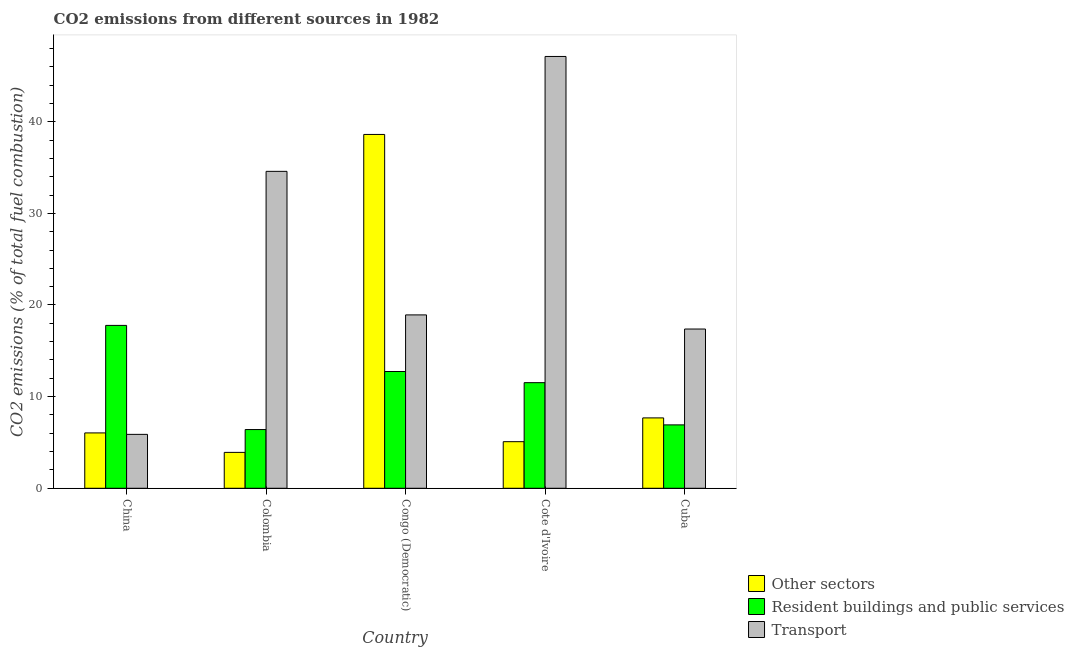How many different coloured bars are there?
Your answer should be compact. 3. Are the number of bars per tick equal to the number of legend labels?
Your answer should be very brief. Yes. How many bars are there on the 5th tick from the left?
Offer a terse response. 3. What is the label of the 3rd group of bars from the left?
Your response must be concise. Congo (Democratic). What is the percentage of co2 emissions from resident buildings and public services in China?
Your answer should be compact. 17.77. Across all countries, what is the maximum percentage of co2 emissions from resident buildings and public services?
Ensure brevity in your answer.  17.77. Across all countries, what is the minimum percentage of co2 emissions from resident buildings and public services?
Provide a succinct answer. 6.41. What is the total percentage of co2 emissions from other sectors in the graph?
Provide a succinct answer. 61.33. What is the difference between the percentage of co2 emissions from resident buildings and public services in China and that in Cuba?
Your answer should be very brief. 10.85. What is the difference between the percentage of co2 emissions from resident buildings and public services in Cuba and the percentage of co2 emissions from other sectors in Colombia?
Give a very brief answer. 3. What is the average percentage of co2 emissions from transport per country?
Provide a succinct answer. 24.78. What is the difference between the percentage of co2 emissions from transport and percentage of co2 emissions from resident buildings and public services in China?
Your answer should be compact. -11.89. In how many countries, is the percentage of co2 emissions from other sectors greater than 34 %?
Offer a terse response. 1. What is the ratio of the percentage of co2 emissions from other sectors in Colombia to that in Cuba?
Provide a short and direct response. 0.51. What is the difference between the highest and the second highest percentage of co2 emissions from resident buildings and public services?
Ensure brevity in your answer.  5.03. What is the difference between the highest and the lowest percentage of co2 emissions from transport?
Make the answer very short. 41.24. In how many countries, is the percentage of co2 emissions from transport greater than the average percentage of co2 emissions from transport taken over all countries?
Your answer should be very brief. 2. What does the 3rd bar from the left in China represents?
Your answer should be compact. Transport. What does the 3rd bar from the right in Congo (Democratic) represents?
Your answer should be very brief. Other sectors. How many bars are there?
Your answer should be compact. 15. Are all the bars in the graph horizontal?
Provide a short and direct response. No. How many countries are there in the graph?
Offer a terse response. 5. Are the values on the major ticks of Y-axis written in scientific E-notation?
Your answer should be very brief. No. Does the graph contain any zero values?
Your answer should be very brief. No. Where does the legend appear in the graph?
Your response must be concise. Bottom right. How many legend labels are there?
Your response must be concise. 3. What is the title of the graph?
Keep it short and to the point. CO2 emissions from different sources in 1982. Does "Labor Tax" appear as one of the legend labels in the graph?
Make the answer very short. No. What is the label or title of the Y-axis?
Provide a succinct answer. CO2 emissions (% of total fuel combustion). What is the CO2 emissions (% of total fuel combustion) of Other sectors in China?
Offer a terse response. 6.04. What is the CO2 emissions (% of total fuel combustion) in Resident buildings and public services in China?
Offer a terse response. 17.77. What is the CO2 emissions (% of total fuel combustion) of Transport in China?
Make the answer very short. 5.88. What is the CO2 emissions (% of total fuel combustion) of Other sectors in Colombia?
Provide a short and direct response. 3.92. What is the CO2 emissions (% of total fuel combustion) in Resident buildings and public services in Colombia?
Give a very brief answer. 6.41. What is the CO2 emissions (% of total fuel combustion) of Transport in Colombia?
Ensure brevity in your answer.  34.58. What is the CO2 emissions (% of total fuel combustion) of Other sectors in Congo (Democratic)?
Offer a very short reply. 38.61. What is the CO2 emissions (% of total fuel combustion) of Resident buildings and public services in Congo (Democratic)?
Make the answer very short. 12.74. What is the CO2 emissions (% of total fuel combustion) of Transport in Congo (Democratic)?
Ensure brevity in your answer.  18.92. What is the CO2 emissions (% of total fuel combustion) of Other sectors in Cote d'Ivoire?
Ensure brevity in your answer.  5.08. What is the CO2 emissions (% of total fuel combustion) in Resident buildings and public services in Cote d'Ivoire?
Your answer should be compact. 11.53. What is the CO2 emissions (% of total fuel combustion) of Transport in Cote d'Ivoire?
Offer a very short reply. 47.12. What is the CO2 emissions (% of total fuel combustion) of Other sectors in Cuba?
Keep it short and to the point. 7.68. What is the CO2 emissions (% of total fuel combustion) in Resident buildings and public services in Cuba?
Provide a succinct answer. 6.92. What is the CO2 emissions (% of total fuel combustion) in Transport in Cuba?
Provide a short and direct response. 17.38. Across all countries, what is the maximum CO2 emissions (% of total fuel combustion) of Other sectors?
Offer a terse response. 38.61. Across all countries, what is the maximum CO2 emissions (% of total fuel combustion) of Resident buildings and public services?
Your answer should be compact. 17.77. Across all countries, what is the maximum CO2 emissions (% of total fuel combustion) in Transport?
Keep it short and to the point. 47.12. Across all countries, what is the minimum CO2 emissions (% of total fuel combustion) in Other sectors?
Keep it short and to the point. 3.92. Across all countries, what is the minimum CO2 emissions (% of total fuel combustion) of Resident buildings and public services?
Your answer should be very brief. 6.41. Across all countries, what is the minimum CO2 emissions (% of total fuel combustion) in Transport?
Make the answer very short. 5.88. What is the total CO2 emissions (% of total fuel combustion) in Other sectors in the graph?
Offer a terse response. 61.33. What is the total CO2 emissions (% of total fuel combustion) in Resident buildings and public services in the graph?
Your answer should be compact. 55.37. What is the total CO2 emissions (% of total fuel combustion) of Transport in the graph?
Keep it short and to the point. 123.88. What is the difference between the CO2 emissions (% of total fuel combustion) of Other sectors in China and that in Colombia?
Make the answer very short. 2.12. What is the difference between the CO2 emissions (% of total fuel combustion) of Resident buildings and public services in China and that in Colombia?
Offer a terse response. 11.37. What is the difference between the CO2 emissions (% of total fuel combustion) of Transport in China and that in Colombia?
Offer a very short reply. -28.7. What is the difference between the CO2 emissions (% of total fuel combustion) of Other sectors in China and that in Congo (Democratic)?
Your response must be concise. -32.57. What is the difference between the CO2 emissions (% of total fuel combustion) of Resident buildings and public services in China and that in Congo (Democratic)?
Make the answer very short. 5.03. What is the difference between the CO2 emissions (% of total fuel combustion) in Transport in China and that in Congo (Democratic)?
Keep it short and to the point. -13.04. What is the difference between the CO2 emissions (% of total fuel combustion) in Other sectors in China and that in Cote d'Ivoire?
Keep it short and to the point. 0.96. What is the difference between the CO2 emissions (% of total fuel combustion) in Resident buildings and public services in China and that in Cote d'Ivoire?
Provide a short and direct response. 6.25. What is the difference between the CO2 emissions (% of total fuel combustion) in Transport in China and that in Cote d'Ivoire?
Keep it short and to the point. -41.24. What is the difference between the CO2 emissions (% of total fuel combustion) in Other sectors in China and that in Cuba?
Your response must be concise. -1.64. What is the difference between the CO2 emissions (% of total fuel combustion) of Resident buildings and public services in China and that in Cuba?
Your answer should be compact. 10.85. What is the difference between the CO2 emissions (% of total fuel combustion) of Transport in China and that in Cuba?
Provide a succinct answer. -11.5. What is the difference between the CO2 emissions (% of total fuel combustion) in Other sectors in Colombia and that in Congo (Democratic)?
Your answer should be compact. -34.69. What is the difference between the CO2 emissions (% of total fuel combustion) of Resident buildings and public services in Colombia and that in Congo (Democratic)?
Offer a terse response. -6.33. What is the difference between the CO2 emissions (% of total fuel combustion) in Transport in Colombia and that in Congo (Democratic)?
Keep it short and to the point. 15.66. What is the difference between the CO2 emissions (% of total fuel combustion) in Other sectors in Colombia and that in Cote d'Ivoire?
Offer a terse response. -1.17. What is the difference between the CO2 emissions (% of total fuel combustion) of Resident buildings and public services in Colombia and that in Cote d'Ivoire?
Offer a terse response. -5.12. What is the difference between the CO2 emissions (% of total fuel combustion) of Transport in Colombia and that in Cote d'Ivoire?
Make the answer very short. -12.54. What is the difference between the CO2 emissions (% of total fuel combustion) in Other sectors in Colombia and that in Cuba?
Give a very brief answer. -3.76. What is the difference between the CO2 emissions (% of total fuel combustion) of Resident buildings and public services in Colombia and that in Cuba?
Your response must be concise. -0.51. What is the difference between the CO2 emissions (% of total fuel combustion) of Transport in Colombia and that in Cuba?
Your answer should be very brief. 17.2. What is the difference between the CO2 emissions (% of total fuel combustion) in Other sectors in Congo (Democratic) and that in Cote d'Ivoire?
Make the answer very short. 33.53. What is the difference between the CO2 emissions (% of total fuel combustion) of Resident buildings and public services in Congo (Democratic) and that in Cote d'Ivoire?
Give a very brief answer. 1.22. What is the difference between the CO2 emissions (% of total fuel combustion) in Transport in Congo (Democratic) and that in Cote d'Ivoire?
Your answer should be very brief. -28.2. What is the difference between the CO2 emissions (% of total fuel combustion) of Other sectors in Congo (Democratic) and that in Cuba?
Offer a terse response. 30.93. What is the difference between the CO2 emissions (% of total fuel combustion) of Resident buildings and public services in Congo (Democratic) and that in Cuba?
Keep it short and to the point. 5.82. What is the difference between the CO2 emissions (% of total fuel combustion) of Transport in Congo (Democratic) and that in Cuba?
Provide a succinct answer. 1.54. What is the difference between the CO2 emissions (% of total fuel combustion) of Other sectors in Cote d'Ivoire and that in Cuba?
Your response must be concise. -2.59. What is the difference between the CO2 emissions (% of total fuel combustion) in Resident buildings and public services in Cote d'Ivoire and that in Cuba?
Provide a short and direct response. 4.61. What is the difference between the CO2 emissions (% of total fuel combustion) in Transport in Cote d'Ivoire and that in Cuba?
Make the answer very short. 29.74. What is the difference between the CO2 emissions (% of total fuel combustion) in Other sectors in China and the CO2 emissions (% of total fuel combustion) in Resident buildings and public services in Colombia?
Make the answer very short. -0.37. What is the difference between the CO2 emissions (% of total fuel combustion) of Other sectors in China and the CO2 emissions (% of total fuel combustion) of Transport in Colombia?
Provide a succinct answer. -28.54. What is the difference between the CO2 emissions (% of total fuel combustion) of Resident buildings and public services in China and the CO2 emissions (% of total fuel combustion) of Transport in Colombia?
Your answer should be compact. -16.81. What is the difference between the CO2 emissions (% of total fuel combustion) of Other sectors in China and the CO2 emissions (% of total fuel combustion) of Resident buildings and public services in Congo (Democratic)?
Your response must be concise. -6.7. What is the difference between the CO2 emissions (% of total fuel combustion) in Other sectors in China and the CO2 emissions (% of total fuel combustion) in Transport in Congo (Democratic)?
Keep it short and to the point. -12.88. What is the difference between the CO2 emissions (% of total fuel combustion) in Resident buildings and public services in China and the CO2 emissions (% of total fuel combustion) in Transport in Congo (Democratic)?
Your answer should be compact. -1.15. What is the difference between the CO2 emissions (% of total fuel combustion) of Other sectors in China and the CO2 emissions (% of total fuel combustion) of Resident buildings and public services in Cote d'Ivoire?
Ensure brevity in your answer.  -5.48. What is the difference between the CO2 emissions (% of total fuel combustion) in Other sectors in China and the CO2 emissions (% of total fuel combustion) in Transport in Cote d'Ivoire?
Your answer should be compact. -41.08. What is the difference between the CO2 emissions (% of total fuel combustion) of Resident buildings and public services in China and the CO2 emissions (% of total fuel combustion) of Transport in Cote d'Ivoire?
Your answer should be compact. -29.35. What is the difference between the CO2 emissions (% of total fuel combustion) of Other sectors in China and the CO2 emissions (% of total fuel combustion) of Resident buildings and public services in Cuba?
Offer a very short reply. -0.88. What is the difference between the CO2 emissions (% of total fuel combustion) in Other sectors in China and the CO2 emissions (% of total fuel combustion) in Transport in Cuba?
Offer a very short reply. -11.34. What is the difference between the CO2 emissions (% of total fuel combustion) in Resident buildings and public services in China and the CO2 emissions (% of total fuel combustion) in Transport in Cuba?
Your answer should be very brief. 0.39. What is the difference between the CO2 emissions (% of total fuel combustion) in Other sectors in Colombia and the CO2 emissions (% of total fuel combustion) in Resident buildings and public services in Congo (Democratic)?
Provide a succinct answer. -8.82. What is the difference between the CO2 emissions (% of total fuel combustion) in Other sectors in Colombia and the CO2 emissions (% of total fuel combustion) in Transport in Congo (Democratic)?
Your answer should be very brief. -15. What is the difference between the CO2 emissions (% of total fuel combustion) of Resident buildings and public services in Colombia and the CO2 emissions (% of total fuel combustion) of Transport in Congo (Democratic)?
Provide a succinct answer. -12.51. What is the difference between the CO2 emissions (% of total fuel combustion) in Other sectors in Colombia and the CO2 emissions (% of total fuel combustion) in Resident buildings and public services in Cote d'Ivoire?
Your answer should be compact. -7.61. What is the difference between the CO2 emissions (% of total fuel combustion) of Other sectors in Colombia and the CO2 emissions (% of total fuel combustion) of Transport in Cote d'Ivoire?
Give a very brief answer. -43.2. What is the difference between the CO2 emissions (% of total fuel combustion) in Resident buildings and public services in Colombia and the CO2 emissions (% of total fuel combustion) in Transport in Cote d'Ivoire?
Offer a very short reply. -40.71. What is the difference between the CO2 emissions (% of total fuel combustion) in Other sectors in Colombia and the CO2 emissions (% of total fuel combustion) in Resident buildings and public services in Cuba?
Offer a terse response. -3. What is the difference between the CO2 emissions (% of total fuel combustion) of Other sectors in Colombia and the CO2 emissions (% of total fuel combustion) of Transport in Cuba?
Your response must be concise. -13.46. What is the difference between the CO2 emissions (% of total fuel combustion) in Resident buildings and public services in Colombia and the CO2 emissions (% of total fuel combustion) in Transport in Cuba?
Offer a terse response. -10.97. What is the difference between the CO2 emissions (% of total fuel combustion) of Other sectors in Congo (Democratic) and the CO2 emissions (% of total fuel combustion) of Resident buildings and public services in Cote d'Ivoire?
Ensure brevity in your answer.  27.08. What is the difference between the CO2 emissions (% of total fuel combustion) in Other sectors in Congo (Democratic) and the CO2 emissions (% of total fuel combustion) in Transport in Cote d'Ivoire?
Keep it short and to the point. -8.51. What is the difference between the CO2 emissions (% of total fuel combustion) in Resident buildings and public services in Congo (Democratic) and the CO2 emissions (% of total fuel combustion) in Transport in Cote d'Ivoire?
Offer a terse response. -34.38. What is the difference between the CO2 emissions (% of total fuel combustion) in Other sectors in Congo (Democratic) and the CO2 emissions (% of total fuel combustion) in Resident buildings and public services in Cuba?
Provide a short and direct response. 31.69. What is the difference between the CO2 emissions (% of total fuel combustion) in Other sectors in Congo (Democratic) and the CO2 emissions (% of total fuel combustion) in Transport in Cuba?
Ensure brevity in your answer.  21.23. What is the difference between the CO2 emissions (% of total fuel combustion) in Resident buildings and public services in Congo (Democratic) and the CO2 emissions (% of total fuel combustion) in Transport in Cuba?
Give a very brief answer. -4.64. What is the difference between the CO2 emissions (% of total fuel combustion) of Other sectors in Cote d'Ivoire and the CO2 emissions (% of total fuel combustion) of Resident buildings and public services in Cuba?
Give a very brief answer. -1.83. What is the difference between the CO2 emissions (% of total fuel combustion) of Other sectors in Cote d'Ivoire and the CO2 emissions (% of total fuel combustion) of Transport in Cuba?
Provide a short and direct response. -12.29. What is the difference between the CO2 emissions (% of total fuel combustion) of Resident buildings and public services in Cote d'Ivoire and the CO2 emissions (% of total fuel combustion) of Transport in Cuba?
Provide a succinct answer. -5.85. What is the average CO2 emissions (% of total fuel combustion) of Other sectors per country?
Offer a very short reply. 12.27. What is the average CO2 emissions (% of total fuel combustion) of Resident buildings and public services per country?
Keep it short and to the point. 11.07. What is the average CO2 emissions (% of total fuel combustion) in Transport per country?
Provide a short and direct response. 24.78. What is the difference between the CO2 emissions (% of total fuel combustion) in Other sectors and CO2 emissions (% of total fuel combustion) in Resident buildings and public services in China?
Your answer should be very brief. -11.73. What is the difference between the CO2 emissions (% of total fuel combustion) in Other sectors and CO2 emissions (% of total fuel combustion) in Transport in China?
Your response must be concise. 0.16. What is the difference between the CO2 emissions (% of total fuel combustion) of Resident buildings and public services and CO2 emissions (% of total fuel combustion) of Transport in China?
Your answer should be compact. 11.89. What is the difference between the CO2 emissions (% of total fuel combustion) of Other sectors and CO2 emissions (% of total fuel combustion) of Resident buildings and public services in Colombia?
Give a very brief answer. -2.49. What is the difference between the CO2 emissions (% of total fuel combustion) in Other sectors and CO2 emissions (% of total fuel combustion) in Transport in Colombia?
Ensure brevity in your answer.  -30.67. What is the difference between the CO2 emissions (% of total fuel combustion) in Resident buildings and public services and CO2 emissions (% of total fuel combustion) in Transport in Colombia?
Offer a terse response. -28.18. What is the difference between the CO2 emissions (% of total fuel combustion) in Other sectors and CO2 emissions (% of total fuel combustion) in Resident buildings and public services in Congo (Democratic)?
Ensure brevity in your answer.  25.87. What is the difference between the CO2 emissions (% of total fuel combustion) in Other sectors and CO2 emissions (% of total fuel combustion) in Transport in Congo (Democratic)?
Offer a terse response. 19.69. What is the difference between the CO2 emissions (% of total fuel combustion) in Resident buildings and public services and CO2 emissions (% of total fuel combustion) in Transport in Congo (Democratic)?
Provide a succinct answer. -6.18. What is the difference between the CO2 emissions (% of total fuel combustion) of Other sectors and CO2 emissions (% of total fuel combustion) of Resident buildings and public services in Cote d'Ivoire?
Offer a terse response. -6.44. What is the difference between the CO2 emissions (% of total fuel combustion) in Other sectors and CO2 emissions (% of total fuel combustion) in Transport in Cote d'Ivoire?
Give a very brief answer. -42.03. What is the difference between the CO2 emissions (% of total fuel combustion) in Resident buildings and public services and CO2 emissions (% of total fuel combustion) in Transport in Cote d'Ivoire?
Your answer should be very brief. -35.59. What is the difference between the CO2 emissions (% of total fuel combustion) of Other sectors and CO2 emissions (% of total fuel combustion) of Resident buildings and public services in Cuba?
Ensure brevity in your answer.  0.76. What is the difference between the CO2 emissions (% of total fuel combustion) of Other sectors and CO2 emissions (% of total fuel combustion) of Transport in Cuba?
Give a very brief answer. -9.7. What is the difference between the CO2 emissions (% of total fuel combustion) of Resident buildings and public services and CO2 emissions (% of total fuel combustion) of Transport in Cuba?
Make the answer very short. -10.46. What is the ratio of the CO2 emissions (% of total fuel combustion) in Other sectors in China to that in Colombia?
Your answer should be very brief. 1.54. What is the ratio of the CO2 emissions (% of total fuel combustion) in Resident buildings and public services in China to that in Colombia?
Keep it short and to the point. 2.77. What is the ratio of the CO2 emissions (% of total fuel combustion) of Transport in China to that in Colombia?
Your answer should be compact. 0.17. What is the ratio of the CO2 emissions (% of total fuel combustion) of Other sectors in China to that in Congo (Democratic)?
Provide a succinct answer. 0.16. What is the ratio of the CO2 emissions (% of total fuel combustion) of Resident buildings and public services in China to that in Congo (Democratic)?
Your answer should be very brief. 1.39. What is the ratio of the CO2 emissions (% of total fuel combustion) of Transport in China to that in Congo (Democratic)?
Provide a succinct answer. 0.31. What is the ratio of the CO2 emissions (% of total fuel combustion) in Other sectors in China to that in Cote d'Ivoire?
Provide a short and direct response. 1.19. What is the ratio of the CO2 emissions (% of total fuel combustion) of Resident buildings and public services in China to that in Cote d'Ivoire?
Your answer should be compact. 1.54. What is the ratio of the CO2 emissions (% of total fuel combustion) in Transport in China to that in Cote d'Ivoire?
Offer a terse response. 0.12. What is the ratio of the CO2 emissions (% of total fuel combustion) in Other sectors in China to that in Cuba?
Offer a very short reply. 0.79. What is the ratio of the CO2 emissions (% of total fuel combustion) in Resident buildings and public services in China to that in Cuba?
Give a very brief answer. 2.57. What is the ratio of the CO2 emissions (% of total fuel combustion) in Transport in China to that in Cuba?
Ensure brevity in your answer.  0.34. What is the ratio of the CO2 emissions (% of total fuel combustion) of Other sectors in Colombia to that in Congo (Democratic)?
Keep it short and to the point. 0.1. What is the ratio of the CO2 emissions (% of total fuel combustion) in Resident buildings and public services in Colombia to that in Congo (Democratic)?
Offer a terse response. 0.5. What is the ratio of the CO2 emissions (% of total fuel combustion) in Transport in Colombia to that in Congo (Democratic)?
Offer a terse response. 1.83. What is the ratio of the CO2 emissions (% of total fuel combustion) of Other sectors in Colombia to that in Cote d'Ivoire?
Your answer should be compact. 0.77. What is the ratio of the CO2 emissions (% of total fuel combustion) of Resident buildings and public services in Colombia to that in Cote d'Ivoire?
Give a very brief answer. 0.56. What is the ratio of the CO2 emissions (% of total fuel combustion) in Transport in Colombia to that in Cote d'Ivoire?
Your answer should be compact. 0.73. What is the ratio of the CO2 emissions (% of total fuel combustion) in Other sectors in Colombia to that in Cuba?
Offer a very short reply. 0.51. What is the ratio of the CO2 emissions (% of total fuel combustion) in Resident buildings and public services in Colombia to that in Cuba?
Provide a short and direct response. 0.93. What is the ratio of the CO2 emissions (% of total fuel combustion) of Transport in Colombia to that in Cuba?
Offer a terse response. 1.99. What is the ratio of the CO2 emissions (% of total fuel combustion) of Other sectors in Congo (Democratic) to that in Cote d'Ivoire?
Provide a succinct answer. 7.59. What is the ratio of the CO2 emissions (% of total fuel combustion) in Resident buildings and public services in Congo (Democratic) to that in Cote d'Ivoire?
Ensure brevity in your answer.  1.11. What is the ratio of the CO2 emissions (% of total fuel combustion) of Transport in Congo (Democratic) to that in Cote d'Ivoire?
Keep it short and to the point. 0.4. What is the ratio of the CO2 emissions (% of total fuel combustion) of Other sectors in Congo (Democratic) to that in Cuba?
Make the answer very short. 5.03. What is the ratio of the CO2 emissions (% of total fuel combustion) of Resident buildings and public services in Congo (Democratic) to that in Cuba?
Give a very brief answer. 1.84. What is the ratio of the CO2 emissions (% of total fuel combustion) of Transport in Congo (Democratic) to that in Cuba?
Your answer should be compact. 1.09. What is the ratio of the CO2 emissions (% of total fuel combustion) in Other sectors in Cote d'Ivoire to that in Cuba?
Provide a short and direct response. 0.66. What is the ratio of the CO2 emissions (% of total fuel combustion) in Resident buildings and public services in Cote d'Ivoire to that in Cuba?
Provide a succinct answer. 1.67. What is the ratio of the CO2 emissions (% of total fuel combustion) in Transport in Cote d'Ivoire to that in Cuba?
Ensure brevity in your answer.  2.71. What is the difference between the highest and the second highest CO2 emissions (% of total fuel combustion) of Other sectors?
Give a very brief answer. 30.93. What is the difference between the highest and the second highest CO2 emissions (% of total fuel combustion) in Resident buildings and public services?
Give a very brief answer. 5.03. What is the difference between the highest and the second highest CO2 emissions (% of total fuel combustion) in Transport?
Give a very brief answer. 12.54. What is the difference between the highest and the lowest CO2 emissions (% of total fuel combustion) in Other sectors?
Ensure brevity in your answer.  34.69. What is the difference between the highest and the lowest CO2 emissions (% of total fuel combustion) in Resident buildings and public services?
Your response must be concise. 11.37. What is the difference between the highest and the lowest CO2 emissions (% of total fuel combustion) in Transport?
Ensure brevity in your answer.  41.24. 